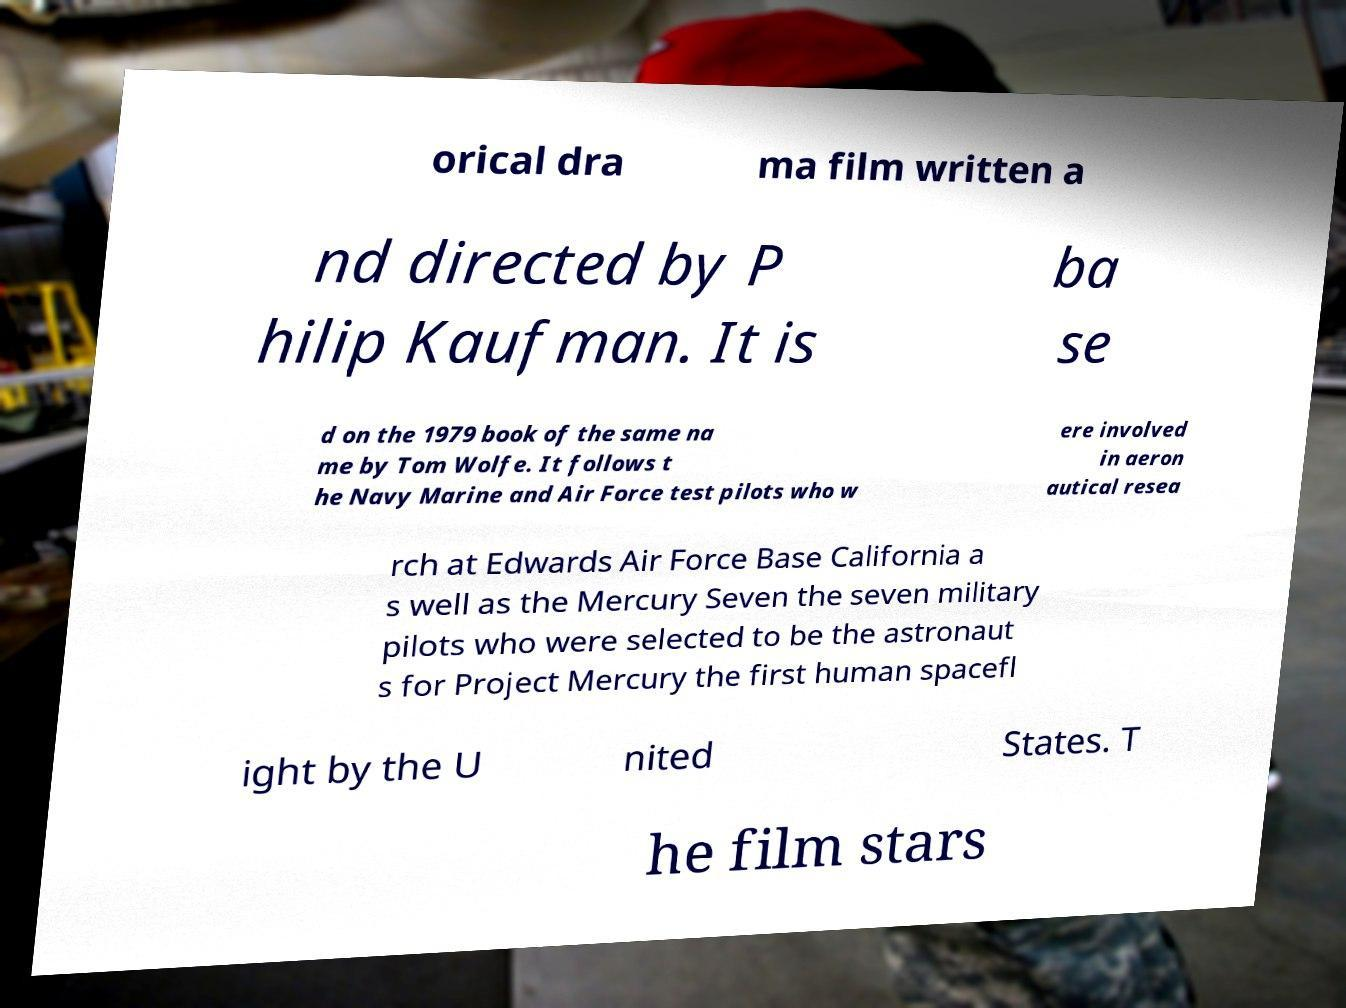Please read and relay the text visible in this image. What does it say? orical dra ma film written a nd directed by P hilip Kaufman. It is ba se d on the 1979 book of the same na me by Tom Wolfe. It follows t he Navy Marine and Air Force test pilots who w ere involved in aeron autical resea rch at Edwards Air Force Base California a s well as the Mercury Seven the seven military pilots who were selected to be the astronaut s for Project Mercury the first human spacefl ight by the U nited States. T he film stars 